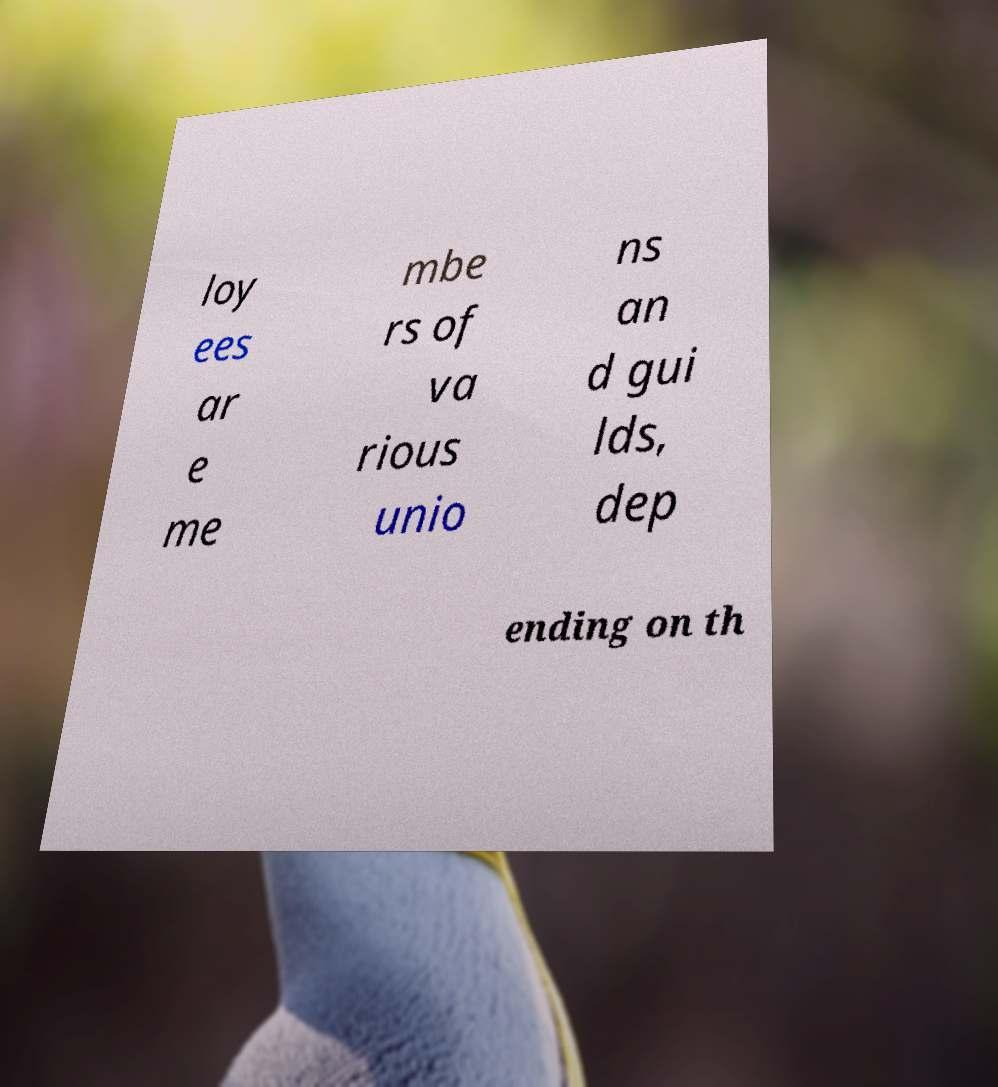For documentation purposes, I need the text within this image transcribed. Could you provide that? loy ees ar e me mbe rs of va rious unio ns an d gui lds, dep ending on th 